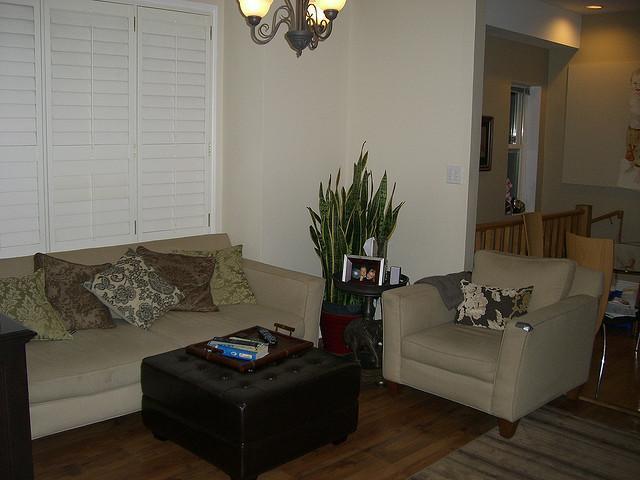How many pictures in the photo?
Give a very brief answer. 1. How many pillows in the chair on the right?
Give a very brief answer. 1. How many people can you see in the picture?
Give a very brief answer. 0. How many chairs do you see?
Give a very brief answer. 3. How many chairs are visible?
Give a very brief answer. 2. How many skis are visible?
Give a very brief answer. 0. 